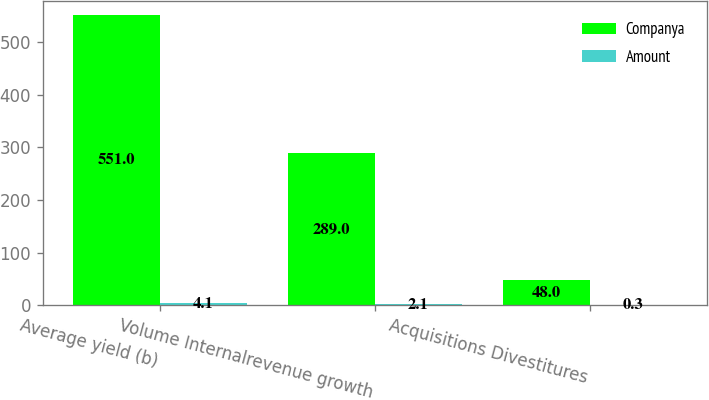Convert chart to OTSL. <chart><loc_0><loc_0><loc_500><loc_500><stacked_bar_chart><ecel><fcel>Average yield (b)<fcel>Volume Internalrevenue growth<fcel>Acquisitions Divestitures<nl><fcel>Companya<fcel>551<fcel>289<fcel>48<nl><fcel>Amount<fcel>4.1<fcel>2.1<fcel>0.3<nl></chart> 